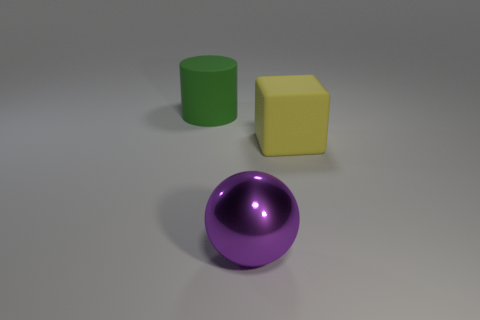Add 3 large purple spheres. How many objects exist? 6 Subtract all balls. How many objects are left? 2 Subtract 0 red blocks. How many objects are left? 3 Subtract all big green metal spheres. Subtract all yellow rubber blocks. How many objects are left? 2 Add 1 yellow blocks. How many yellow blocks are left? 2 Add 2 tiny cyan metallic spheres. How many tiny cyan metallic spheres exist? 2 